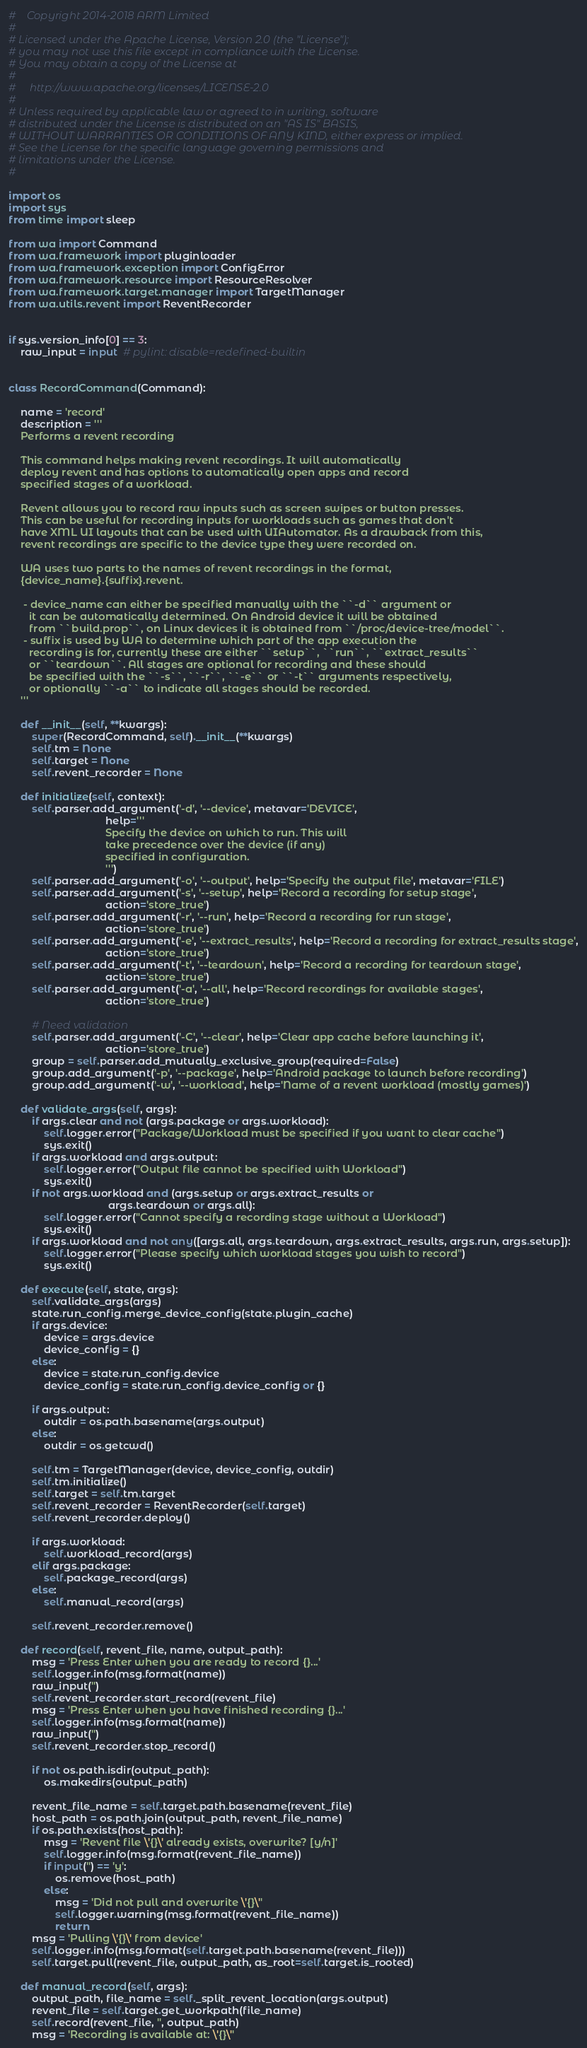<code> <loc_0><loc_0><loc_500><loc_500><_Python_>#    Copyright 2014-2018 ARM Limited
#
# Licensed under the Apache License, Version 2.0 (the "License");
# you may not use this file except in compliance with the License.
# You may obtain a copy of the License at
#
#     http://www.apache.org/licenses/LICENSE-2.0
#
# Unless required by applicable law or agreed to in writing, software
# distributed under the License is distributed on an "AS IS" BASIS,
# WITHOUT WARRANTIES OR CONDITIONS OF ANY KIND, either express or implied.
# See the License for the specific language governing permissions and
# limitations under the License.
#

import os
import sys
from time import sleep

from wa import Command
from wa.framework import pluginloader
from wa.framework.exception import ConfigError
from wa.framework.resource import ResourceResolver
from wa.framework.target.manager import TargetManager
from wa.utils.revent import ReventRecorder


if sys.version_info[0] == 3:
    raw_input = input  # pylint: disable=redefined-builtin


class RecordCommand(Command):

    name = 'record'
    description = '''
    Performs a revent recording

    This command helps making revent recordings. It will automatically
    deploy revent and has options to automatically open apps and record
    specified stages of a workload.

    Revent allows you to record raw inputs such as screen swipes or button presses.
    This can be useful for recording inputs for workloads such as games that don't
    have XML UI layouts that can be used with UIAutomator. As a drawback from this,
    revent recordings are specific to the device type they were recorded on.

    WA uses two parts to the names of revent recordings in the format,
    {device_name}.{suffix}.revent.

     - device_name can either be specified manually with the ``-d`` argument or
       it can be automatically determined. On Android device it will be obtained
       from ``build.prop``, on Linux devices it is obtained from ``/proc/device-tree/model``.
     - suffix is used by WA to determine which part of the app execution the
       recording is for, currently these are either ``setup``, ``run``, ``extract_results``
       or ``teardown``. All stages are optional for recording and these should
       be specified with the ``-s``, ``-r``, ``-e`` or ``-t`` arguments respectively,
       or optionally ``-a`` to indicate all stages should be recorded.
    '''

    def __init__(self, **kwargs):
        super(RecordCommand, self).__init__(**kwargs)
        self.tm = None
        self.target = None
        self.revent_recorder = None

    def initialize(self, context):
        self.parser.add_argument('-d', '--device', metavar='DEVICE',
                                 help='''
                                 Specify the device on which to run. This will
                                 take precedence over the device (if any)
                                 specified in configuration.
                                 ''')
        self.parser.add_argument('-o', '--output', help='Specify the output file', metavar='FILE')
        self.parser.add_argument('-s', '--setup', help='Record a recording for setup stage',
                                 action='store_true')
        self.parser.add_argument('-r', '--run', help='Record a recording for run stage',
                                 action='store_true')
        self.parser.add_argument('-e', '--extract_results', help='Record a recording for extract_results stage',
                                 action='store_true')
        self.parser.add_argument('-t', '--teardown', help='Record a recording for teardown stage',
                                 action='store_true')
        self.parser.add_argument('-a', '--all', help='Record recordings for available stages',
                                 action='store_true')

        # Need validation
        self.parser.add_argument('-C', '--clear', help='Clear app cache before launching it',
                                 action='store_true')
        group = self.parser.add_mutually_exclusive_group(required=False)
        group.add_argument('-p', '--package', help='Android package to launch before recording')
        group.add_argument('-w', '--workload', help='Name of a revent workload (mostly games)')

    def validate_args(self, args):
        if args.clear and not (args.package or args.workload):
            self.logger.error("Package/Workload must be specified if you want to clear cache")
            sys.exit()
        if args.workload and args.output:
            self.logger.error("Output file cannot be specified with Workload")
            sys.exit()
        if not args.workload and (args.setup or args.extract_results or
                                  args.teardown or args.all):
            self.logger.error("Cannot specify a recording stage without a Workload")
            sys.exit()
        if args.workload and not any([args.all, args.teardown, args.extract_results, args.run, args.setup]):
            self.logger.error("Please specify which workload stages you wish to record")
            sys.exit()

    def execute(self, state, args):
        self.validate_args(args)
        state.run_config.merge_device_config(state.plugin_cache)
        if args.device:
            device = args.device
            device_config = {}
        else:
            device = state.run_config.device
            device_config = state.run_config.device_config or {}

        if args.output:
            outdir = os.path.basename(args.output)
        else:
            outdir = os.getcwd()

        self.tm = TargetManager(device, device_config, outdir)
        self.tm.initialize()
        self.target = self.tm.target
        self.revent_recorder = ReventRecorder(self.target)
        self.revent_recorder.deploy()

        if args.workload:
            self.workload_record(args)
        elif args.package:
            self.package_record(args)
        else:
            self.manual_record(args)

        self.revent_recorder.remove()

    def record(self, revent_file, name, output_path):
        msg = 'Press Enter when you are ready to record {}...'
        self.logger.info(msg.format(name))
        raw_input('')
        self.revent_recorder.start_record(revent_file)
        msg = 'Press Enter when you have finished recording {}...'
        self.logger.info(msg.format(name))
        raw_input('')
        self.revent_recorder.stop_record()

        if not os.path.isdir(output_path):
            os.makedirs(output_path)

        revent_file_name = self.target.path.basename(revent_file)
        host_path = os.path.join(output_path, revent_file_name)
        if os.path.exists(host_path):
            msg = 'Revent file \'{}\' already exists, overwrite? [y/n]'
            self.logger.info(msg.format(revent_file_name))
            if input('') == 'y':
                os.remove(host_path)
            else:
                msg = 'Did not pull and overwrite \'{}\''
                self.logger.warning(msg.format(revent_file_name))
                return
        msg = 'Pulling \'{}\' from device'
        self.logger.info(msg.format(self.target.path.basename(revent_file)))
        self.target.pull(revent_file, output_path, as_root=self.target.is_rooted)

    def manual_record(self, args):
        output_path, file_name = self._split_revent_location(args.output)
        revent_file = self.target.get_workpath(file_name)
        self.record(revent_file, '', output_path)
        msg = 'Recording is available at: \'{}\''</code> 